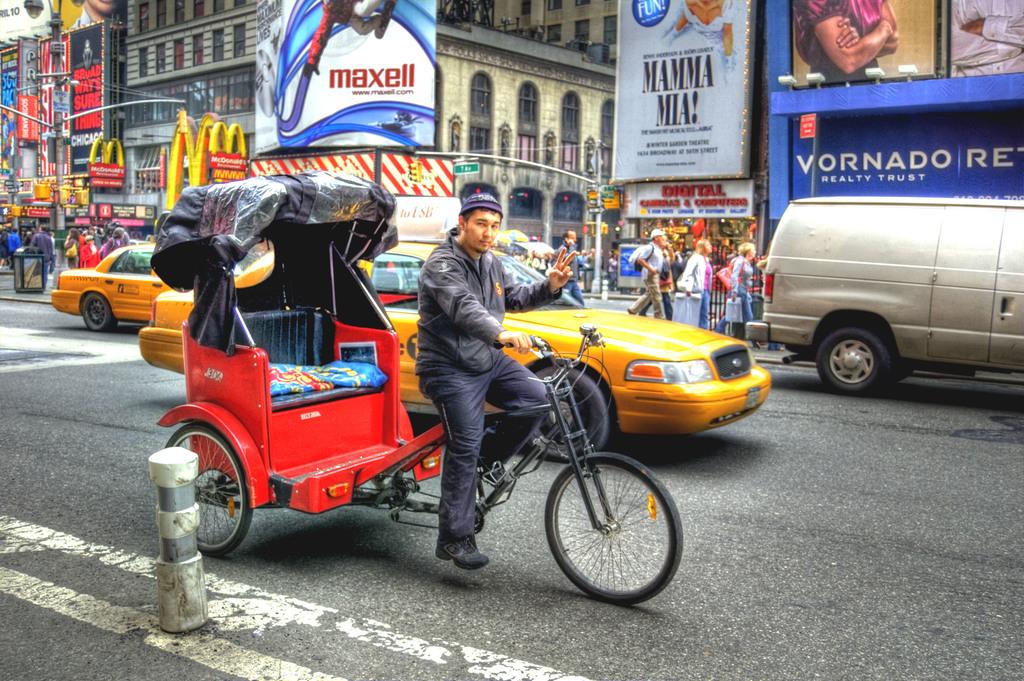What is one of the broadway show ads in this photo?
Make the answer very short. Mamma mia. What does the company vornado in the blue ad sell?
Your answer should be very brief. Realty trust. 